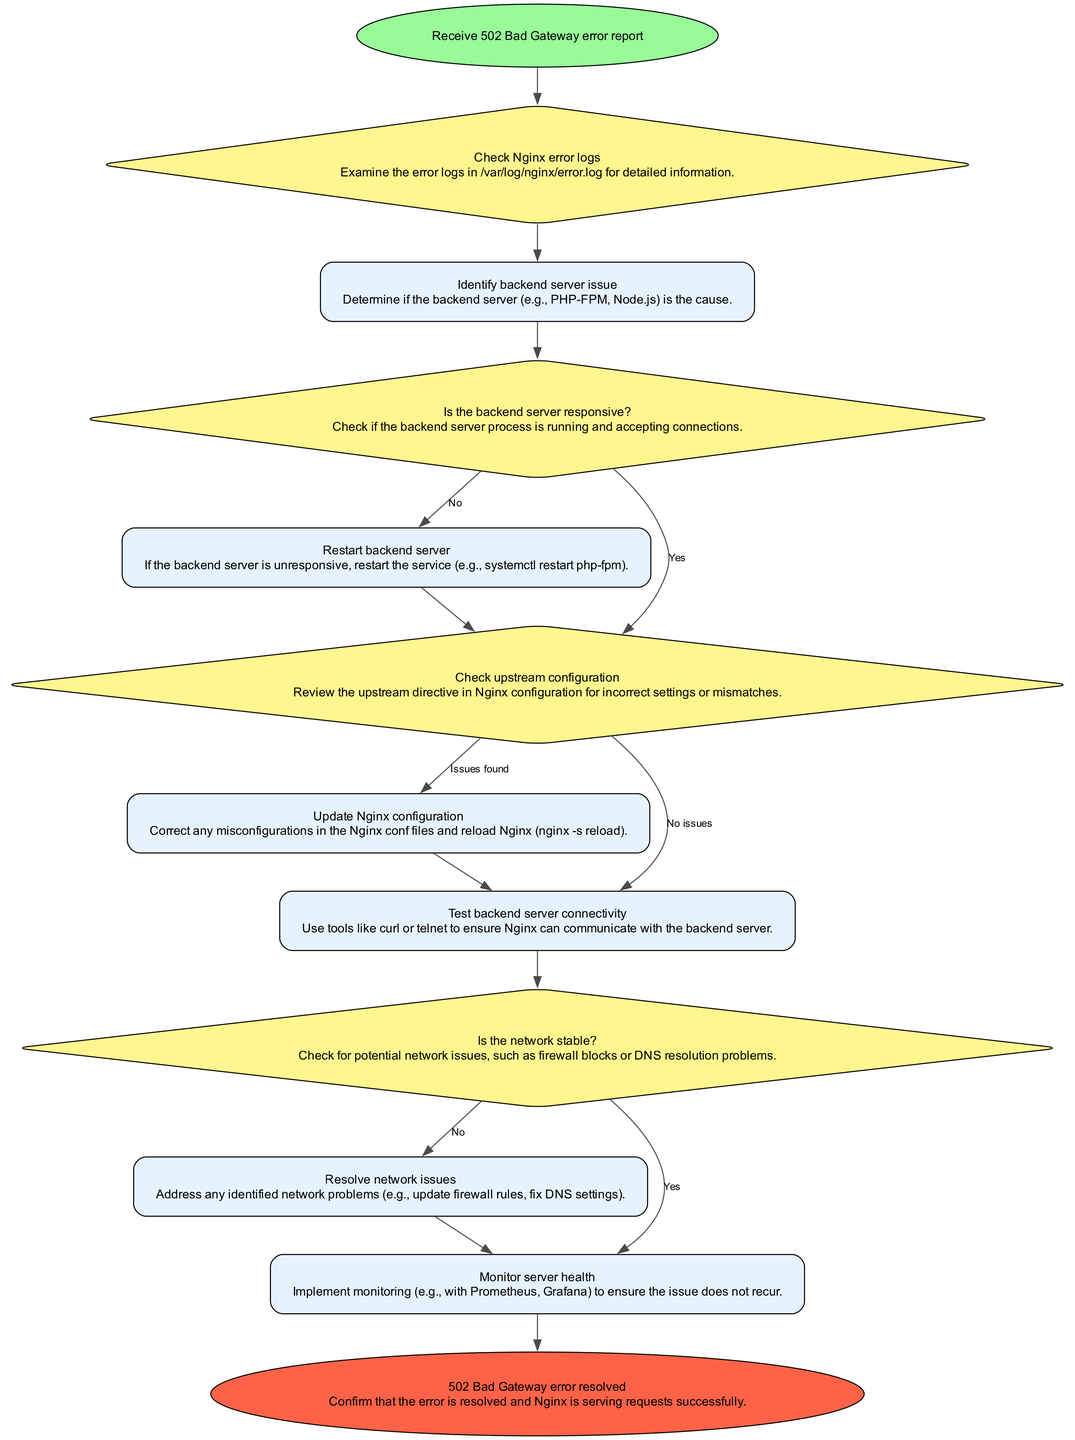What is the first step in handling a 502 Bad Gateway error? The diagram indicates that the first step is "Receive 502 Bad Gateway error report," which is represented as the starting node.
Answer: Receive 502 Bad Gateway error report How many decision nodes are in the flowchart? The flowchart contains four decision nodes. They are: "Check Nginx error logs," "Is the backend server responsive?," "Check upstream configuration," and "Is the network stable?"
Answer: Four What action is taken if the backend server is unresponsive? According to the diagram, if the backend server is unresponsive (indicated by the decision node), the action taken is to "Restart backend server."
Answer: Restart backend server What is the next step after updating the Nginx configuration? The next step after "Update Nginx configuration" is to "Test backend server connectivity," as indicated by the arrows in the flowchart directing from one process to the next.
Answer: Test backend server connectivity What must be done if network issues are detected? If network issues are detected, the next step outlined in the diagram is to "Resolve network issues," which refers to addressing any identified problems.
Answer: Resolve network issues What does the flowchart indicate happens after “Test backend server connectivity”? The flowchart shows that after “Test backend server connectivity,” there is a decision node labeled “Is the network stable?” which determines the path for subsequent actions.
Answer: Is the network stable? What does the final outcome of the process state in the flowchart? The final outcome of the process is stated as "502 Bad Gateway error resolved," confirming that the error has been addressed.
Answer: 502 Bad Gateway error resolved What is the relationship between “Check upstream configuration” and “Update Nginx configuration”? The relationship is that "Check upstream configuration" leads to two pathways: if issues are found, it leads to "Update Nginx configuration," otherwise it continues to "Test backend server connectivity."
Answer: Check upstream configuration leads to Update Nginx configuration or Test backend server connectivity 